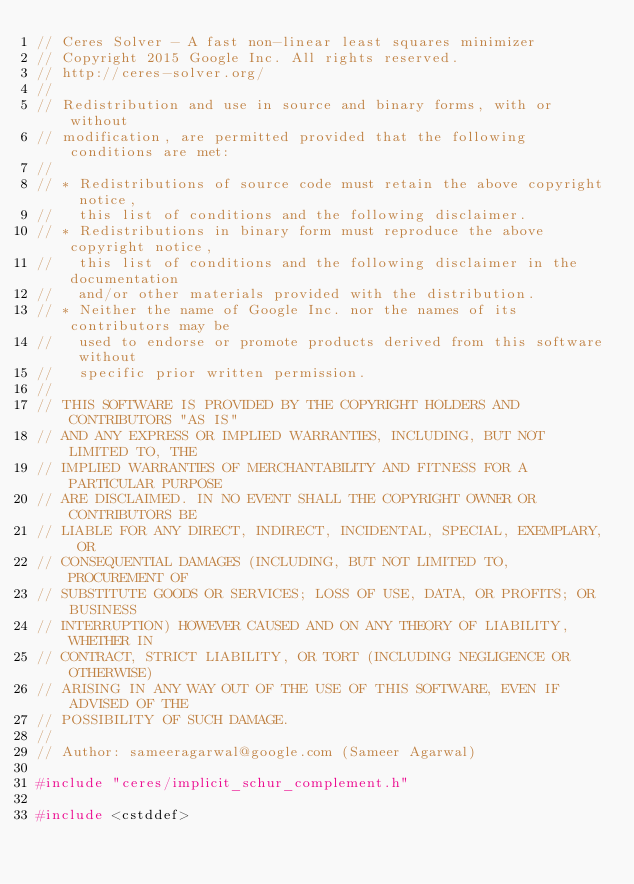Convert code to text. <code><loc_0><loc_0><loc_500><loc_500><_C++_>// Ceres Solver - A fast non-linear least squares minimizer
// Copyright 2015 Google Inc. All rights reserved.
// http://ceres-solver.org/
//
// Redistribution and use in source and binary forms, with or without
// modification, are permitted provided that the following conditions are met:
//
// * Redistributions of source code must retain the above copyright notice,
//   this list of conditions and the following disclaimer.
// * Redistributions in binary form must reproduce the above copyright notice,
//   this list of conditions and the following disclaimer in the documentation
//   and/or other materials provided with the distribution.
// * Neither the name of Google Inc. nor the names of its contributors may be
//   used to endorse or promote products derived from this software without
//   specific prior written permission.
//
// THIS SOFTWARE IS PROVIDED BY THE COPYRIGHT HOLDERS AND CONTRIBUTORS "AS IS"
// AND ANY EXPRESS OR IMPLIED WARRANTIES, INCLUDING, BUT NOT LIMITED TO, THE
// IMPLIED WARRANTIES OF MERCHANTABILITY AND FITNESS FOR A PARTICULAR PURPOSE
// ARE DISCLAIMED. IN NO EVENT SHALL THE COPYRIGHT OWNER OR CONTRIBUTORS BE
// LIABLE FOR ANY DIRECT, INDIRECT, INCIDENTAL, SPECIAL, EXEMPLARY, OR
// CONSEQUENTIAL DAMAGES (INCLUDING, BUT NOT LIMITED TO, PROCUREMENT OF
// SUBSTITUTE GOODS OR SERVICES; LOSS OF USE, DATA, OR PROFITS; OR BUSINESS
// INTERRUPTION) HOWEVER CAUSED AND ON ANY THEORY OF LIABILITY, WHETHER IN
// CONTRACT, STRICT LIABILITY, OR TORT (INCLUDING NEGLIGENCE OR OTHERWISE)
// ARISING IN ANY WAY OUT OF THE USE OF THIS SOFTWARE, EVEN IF ADVISED OF THE
// POSSIBILITY OF SUCH DAMAGE.
//
// Author: sameeragarwal@google.com (Sameer Agarwal)

#include "ceres/implicit_schur_complement.h"

#include <cstddef></code> 